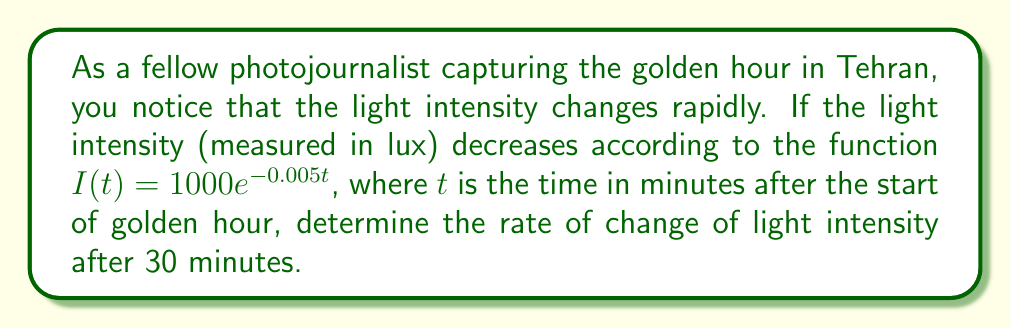Teach me how to tackle this problem. To solve this problem, we need to follow these steps:

1) The given function for light intensity is:
   $I(t) = 1000e^{-0.005t}$

2) To find the rate of change, we need to calculate the derivative of this function with respect to time:
   
   $\frac{dI}{dt} = 1000 \cdot (-0.005) \cdot e^{-0.005t}$
   
   $\frac{dI}{dt} = -5e^{-0.005t}$

3) This derivative gives us the instantaneous rate of change of light intensity at any time $t$.

4) To find the rate of change after 30 minutes, we substitute $t = 30$ into our derivative function:

   $\frac{dI}{dt}|_{t=30} = -5e^{-0.005(30)}$
   
   $= -5e^{-0.15}$
   
   $\approx -4.30$ lux/minute

5) The negative value indicates that the light intensity is decreasing.
Answer: The rate of change of light intensity after 30 minutes is approximately $-4.30$ lux per minute. 